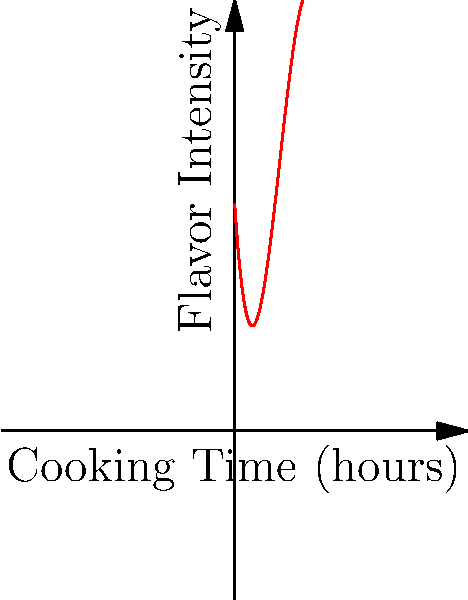As a documentary filmmaker exploring the relationship between cooking time and flavor intensity for a traditional slow-cooked stew, you've gathered data and plotted it as shown in the graph. The curve represents the flavor intensity as a function of cooking time. At which point does the stew reach its peak flavor intensity? To find the peak flavor intensity, we need to analyze the curve:

1. The curve is a polynomial function representing flavor intensity over cooking time.
2. The peak of the curve represents the maximum flavor intensity.
3. We can see three labeled points on the curve: A, B, and C.
4. Point A is at the beginning of the curve, representing early cooking stages.
5. Point C is at the end of the curve, showing extended cooking time.
6. Point B is at the highest point of the curve, between A and C.
7. Since B is at the vertex of the parabola-like section of the curve, it represents the maximum flavor intensity.
8. The x-coordinate of point B corresponds to the cooking time that yields the peak flavor.

Therefore, point B represents the time at which the stew reaches its peak flavor intensity.
Answer: B 